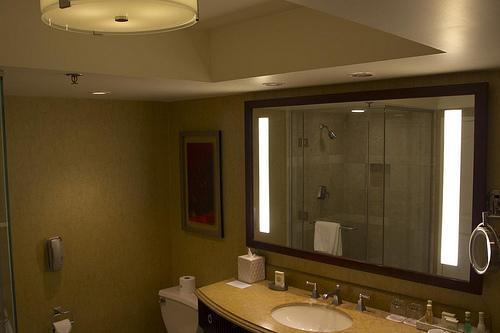How many phones are on the wall?
Give a very brief answer. 1. How many sinks are pictured?
Give a very brief answer. 1. How many dinosaurs are in the picture?
Give a very brief answer. 0. How many people are eating donuts?
Give a very brief answer. 0. How many elephants are pictured?
Give a very brief answer. 0. How many toilet paper rolls are to the right of the sink?
Give a very brief answer. 2. 